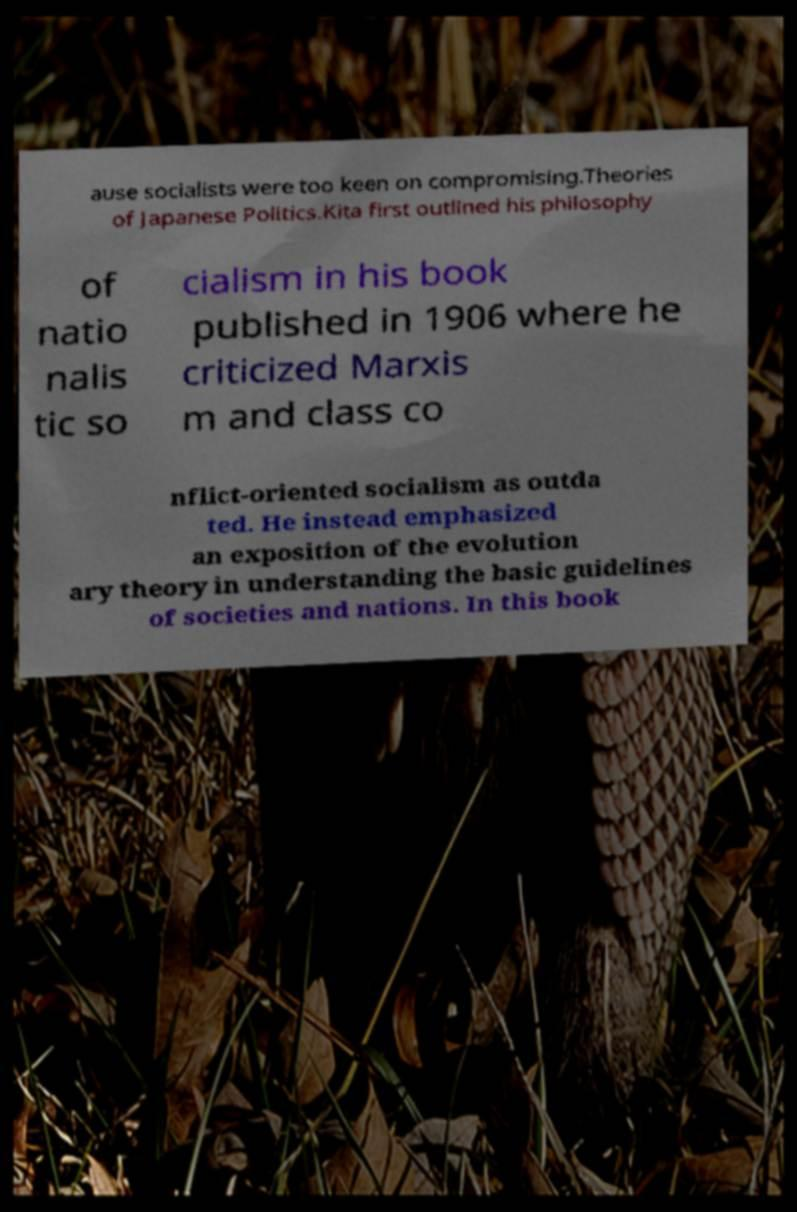There's text embedded in this image that I need extracted. Can you transcribe it verbatim? ause socialists were too keen on compromising.Theories of Japanese Politics.Kita first outlined his philosophy of natio nalis tic so cialism in his book published in 1906 where he criticized Marxis m and class co nflict-oriented socialism as outda ted. He instead emphasized an exposition of the evolution ary theory in understanding the basic guidelines of societies and nations. In this book 